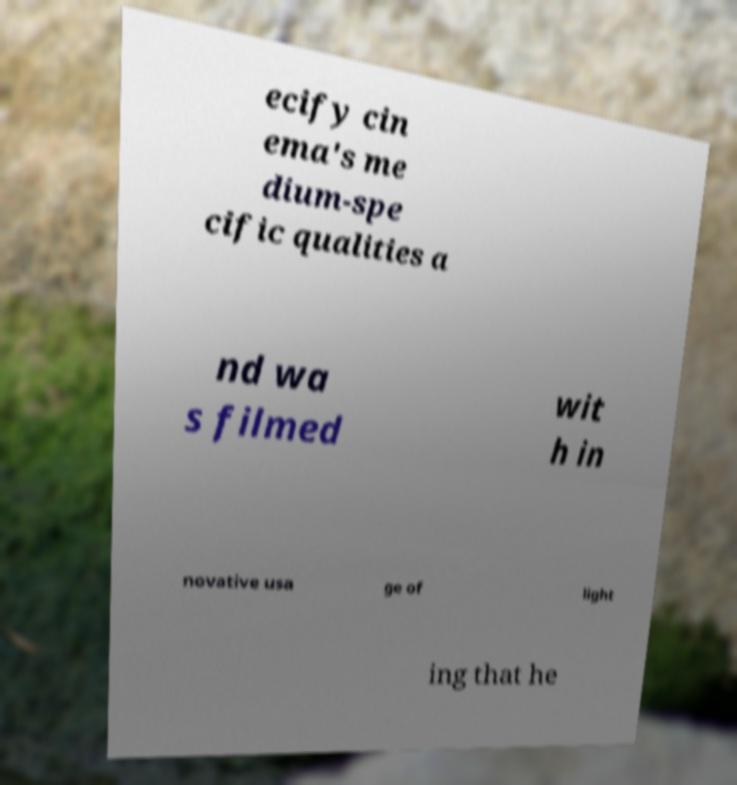Please read and relay the text visible in this image. What does it say? ecify cin ema's me dium-spe cific qualities a nd wa s filmed wit h in novative usa ge of light ing that he 